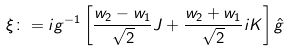<formula> <loc_0><loc_0><loc_500><loc_500>\xi \colon = i g ^ { - 1 } \left [ \frac { w _ { 2 } - w _ { 1 } } { \sqrt { 2 } } J + \frac { w _ { 2 } + w _ { 1 } } { \sqrt { 2 } } i K \right ] \hat { g }</formula> 